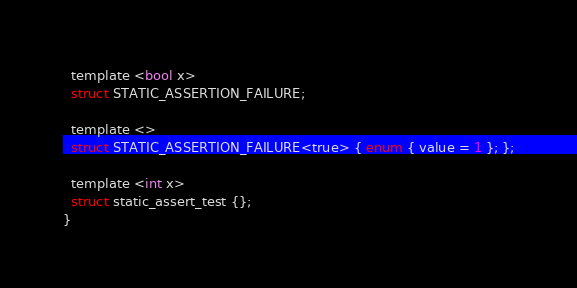Convert code to text. <code><loc_0><loc_0><loc_500><loc_500><_C_>  template <bool x>
  struct STATIC_ASSERTION_FAILURE;

  template <>
  struct STATIC_ASSERTION_FAILURE<true> { enum { value = 1 }; };

  template <int x>
  struct static_assert_test {};
}
</code> 